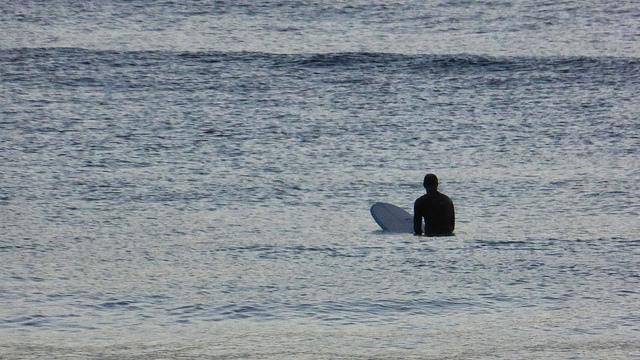Is the man drowning?
Keep it brief. No. Who is in the water?
Give a very brief answer. Surfer. How many people are in the water?
Short answer required. 1. What sport is the man participating in?
Keep it brief. Surfing. 